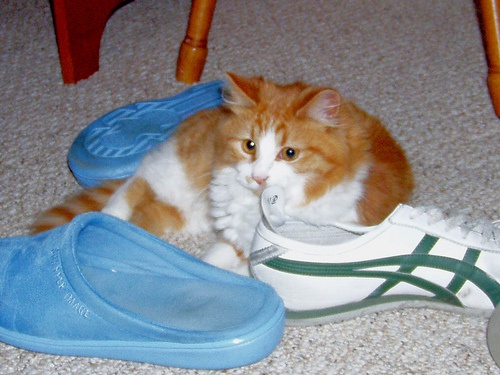Describe the objects in this image and their specific colors. I can see a cat in black, lightgray, brown, gray, and darkgray tones in this image. 